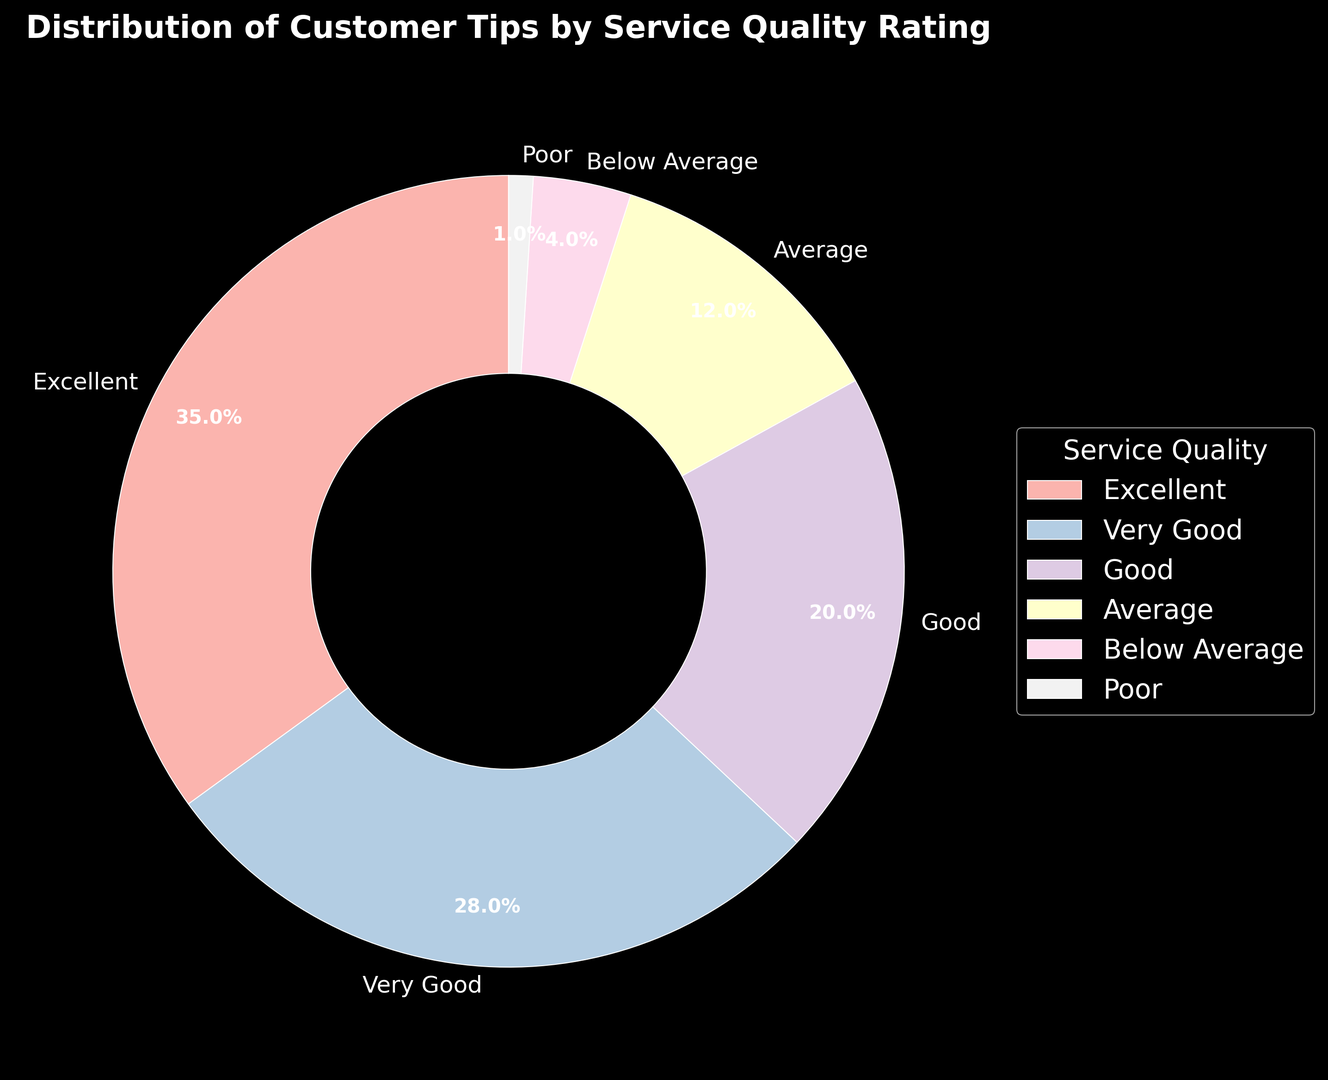What's the largest percentage of tips received by any service quality rating? The pie chart shows that the "Excellent" service quality rating has the largest wedge, which corresponds to 35% of tips.
Answer: 35% Which two service quality ratings collectively receive over 60% of the tips? We need to identify two services whose combined total is more than 60%. "Excellent" has 35% and "Very Good" has 28%. Together, 35% + 28% = 63%.
Answer: Excellent and Very Good How much more does the "Excellent" rating receive compared to the "Average" rating? Subtract the percentage of tips received by "Average" (12%) from "Excellent" (35%). 35% - 12% = 23%.
Answer: 23% What is the combined percentage of tips received by the "Poor" and "Below Average" ratings? Add the percentages of "Poor" (1%) and "Below Average" (4%). 1% + 4% = 5%.
Answer: 5% Which ratings receive more tips than the "Good" rating? The pie chart shows that "Excellent" (35%) and "Very Good" (28%) both receive more tips than "Good" (20%).
Answer: Excellent and Very Good What percentage of tips does the "Good" and "Very Good" ratings combined receive? Add the percentages of "Good" (20%) and "Very Good" (28%). 20% + 28% = 48%.
Answer: 48% Which segment has the smallest representation in the pie chart and by how much? The "Poor" rating has the smallest representation at 1%. It can be concluded by seeing that its wedge is the smallest in the pie chart.
Answer: 1% Compare the visual size of wedges for "Average" and "Very Good." Which one is larger? The wedge for "Very Good" (28%) is larger than the wedge for "Average" (12%) as 28% is greater than 12%. The visual size correlates with their respective percentages.
Answer: Very Good If we combine "Below Average" and "Average" ratings, do they make up at least 20% of the tips? Add the percentages of "Below Average" (4%) and "Average" (12%). 4% + 12% = 16%, which is less than 20%.
Answer: No What distinguishes the "Excellent" rating from the others in terms of representation? The "Excellent" rating has the most significant visual representation in the pie chart at 35%, which means it receives the highest portion of tips.
Answer: Highest percentage at 35% 